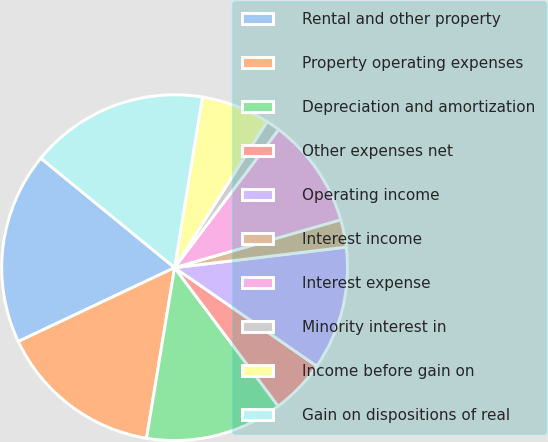<chart> <loc_0><loc_0><loc_500><loc_500><pie_chart><fcel>Rental and other property<fcel>Property operating expenses<fcel>Depreciation and amortization<fcel>Other expenses net<fcel>Operating income<fcel>Interest income<fcel>Interest expense<fcel>Minority interest in<fcel>Income before gain on<fcel>Gain on dispositions of real<nl><fcel>17.94%<fcel>15.38%<fcel>12.82%<fcel>5.13%<fcel>11.54%<fcel>2.57%<fcel>10.26%<fcel>1.29%<fcel>6.41%<fcel>16.66%<nl></chart> 